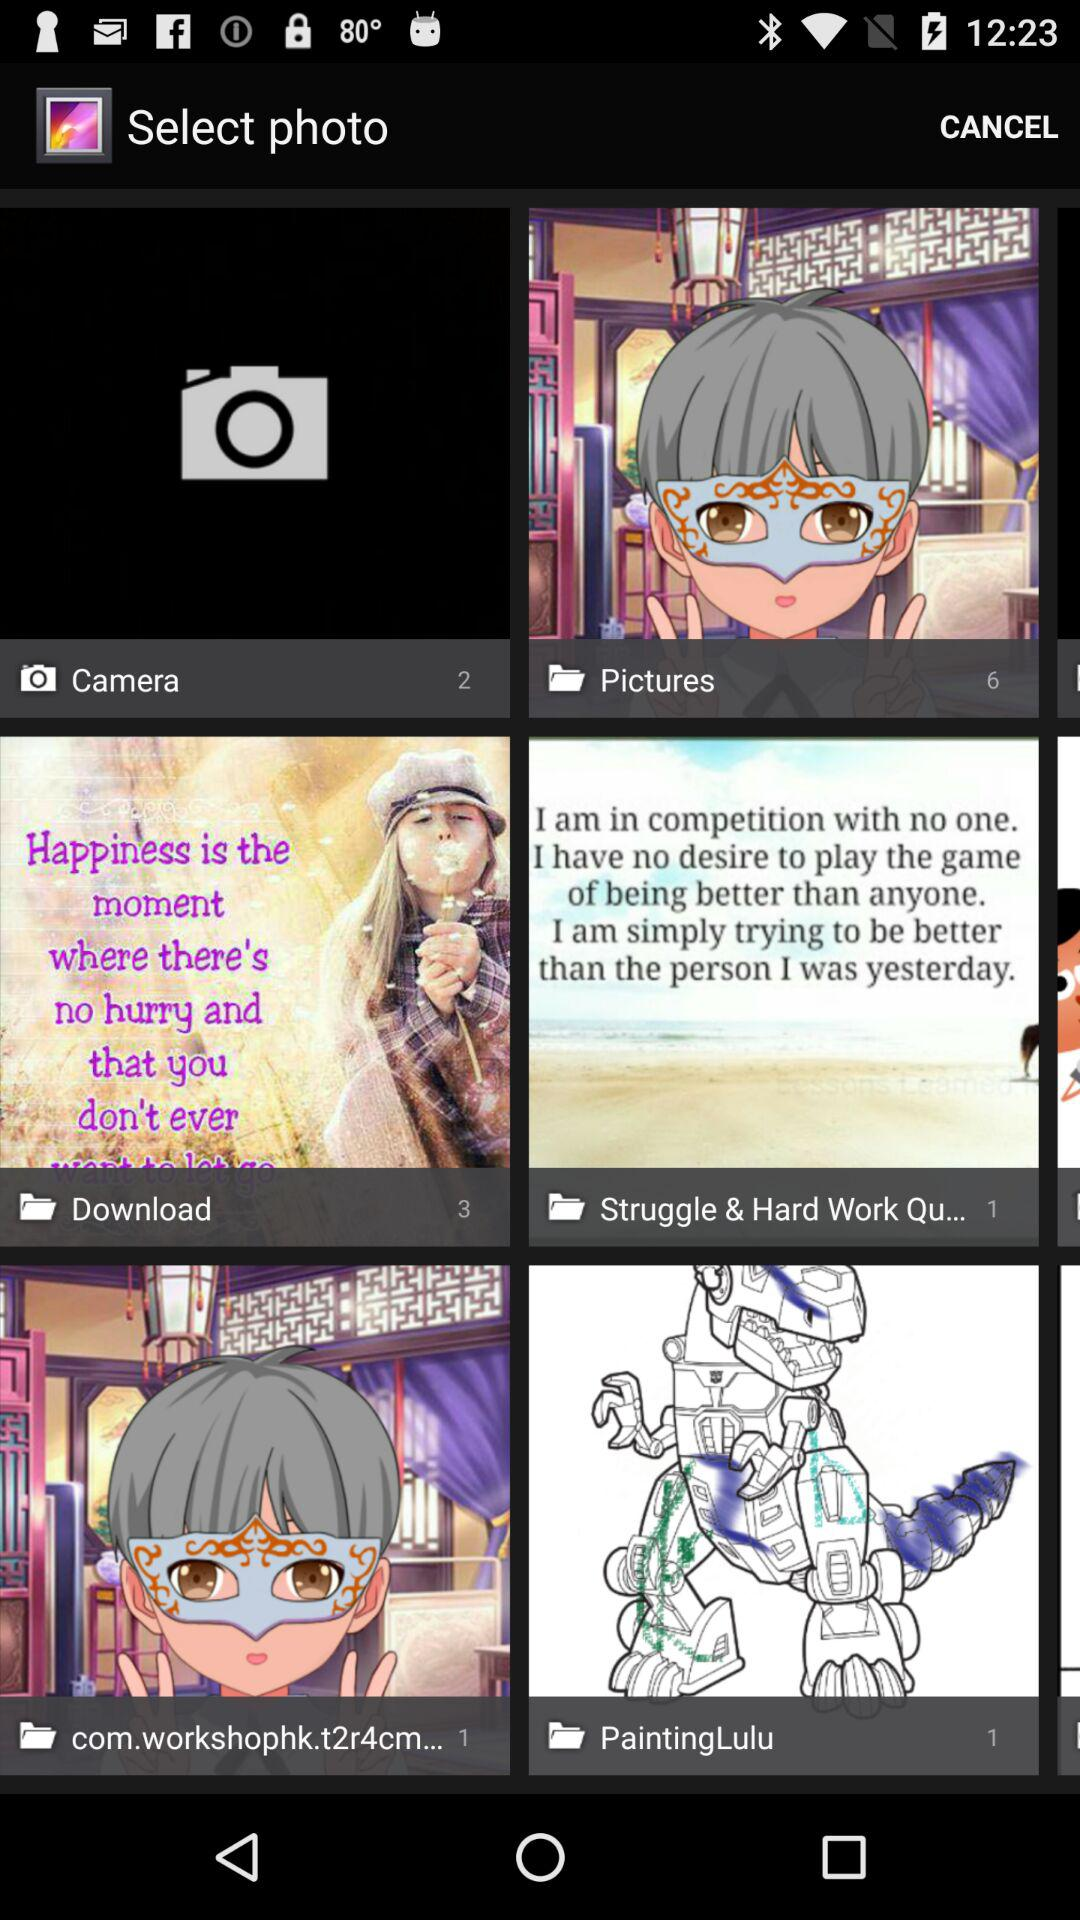What is the total number of images in the "Download" folder? The total number of images in the "Download" folder is 3. 